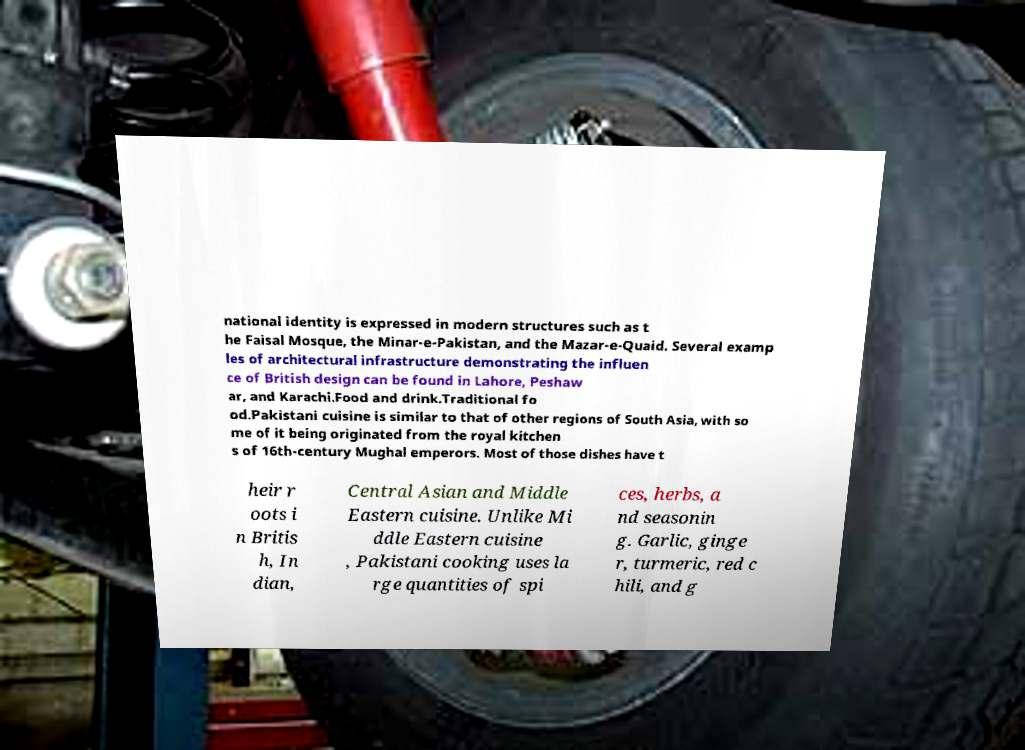For documentation purposes, I need the text within this image transcribed. Could you provide that? national identity is expressed in modern structures such as t he Faisal Mosque, the Minar-e-Pakistan, and the Mazar-e-Quaid. Several examp les of architectural infrastructure demonstrating the influen ce of British design can be found in Lahore, Peshaw ar, and Karachi.Food and drink.Traditional fo od.Pakistani cuisine is similar to that of other regions of South Asia, with so me of it being originated from the royal kitchen s of 16th-century Mughal emperors. Most of those dishes have t heir r oots i n Britis h, In dian, Central Asian and Middle Eastern cuisine. Unlike Mi ddle Eastern cuisine , Pakistani cooking uses la rge quantities of spi ces, herbs, a nd seasonin g. Garlic, ginge r, turmeric, red c hili, and g 